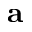<formula> <loc_0><loc_0><loc_500><loc_500>{ a }</formula> 